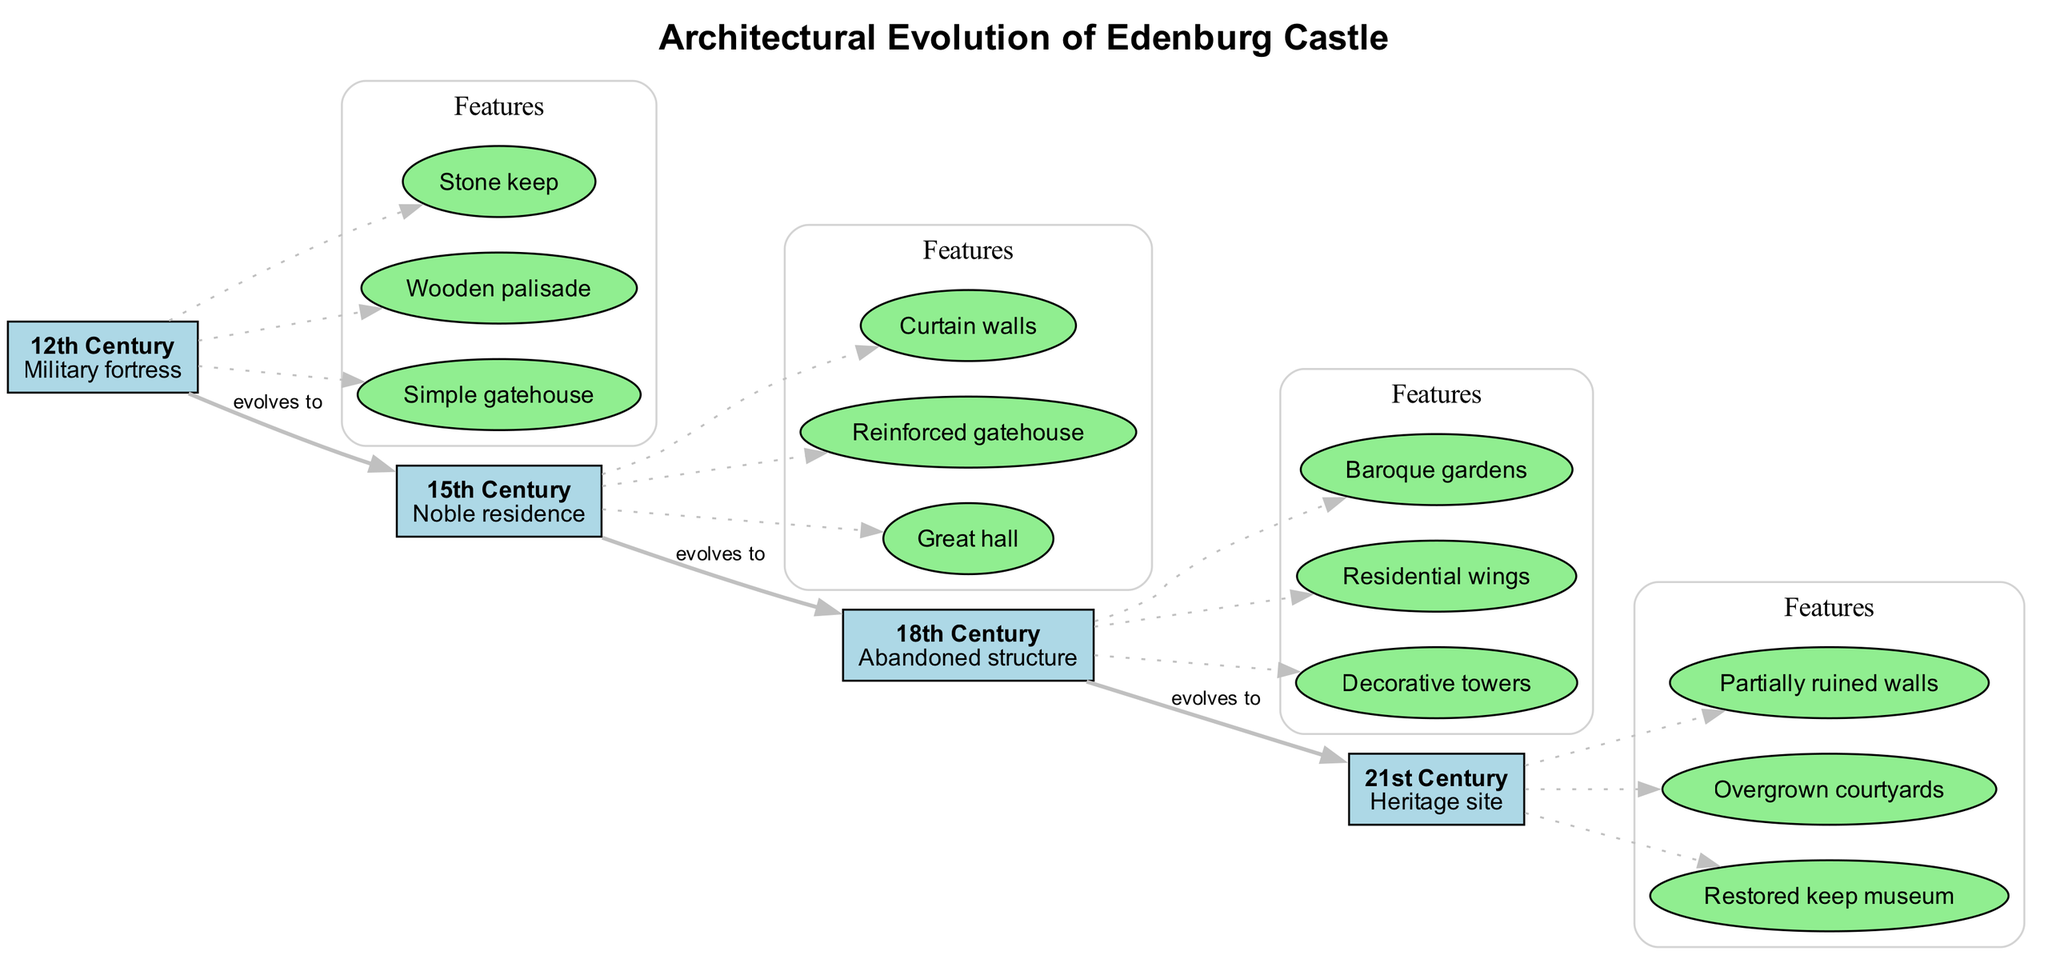What features are present in the 18th Century era? The diagram clearly lists the features associated with the 18th Century era, which include "Baroque gardens," "Residential wings," and "Decorative towers."
Answer: Baroque gardens, Residential wings, Decorative towers How many features are listed for the 12th Century? The 12th Century era displays three features: "Stone keep," "Wooden palisade," and "Simple gatehouse," as noted in the subgraph for that era. Counting these gives a total of three features.
Answer: 3 What type of structure does Edenburg Castle evolve from in the 12th Century? Looking at the flow of the diagram, the 12th Century node indicates that it represents a military fortress, which shows the initial purpose of the castle.
Answer: Military fortress Which cultural shift corresponds with the 21st Century era? The diagram indicates that the cultural shift related to the 21st Century is categorized as a "Heritage site," which reflects the contemporary significance of the location.
Answer: Heritage site What structural change occurs from the 15th to the 18th Century? Observing the diagram from the 15th Century to the 18th Century, the notable changes are the addition of "Baroque gardens" and "Residential wings," indicating a shift in functionality and aesthetics.
Answer: Baroque gardens, Residential wings What is the last feature listed for the 21st Century? The features associated with the 21st Century era include "Partially ruined walls," "Overgrown courtyards," and "Restored keep museum," with "Restored keep museum" being the last one listed.
Answer: Restored keep museum How many eras are depicted in the diagram? The diagram lists four distinct eras: 12th Century, 15th Century, 18th Century, and 21st Century, making a total of four eras.
Answer: 4 What is the evolution of the structure's purpose from the 12th to the 21st Century? The diagram illustrates a transformation that starts from a "Military fortress" in the 12th Century, transitioning to a "Noble residence" in the 15th Century, then becoming an "Abandoned structure," and ultimately evolving into a "Heritage site" in the 21st Century.
Answer: Military fortress to Heritage site 